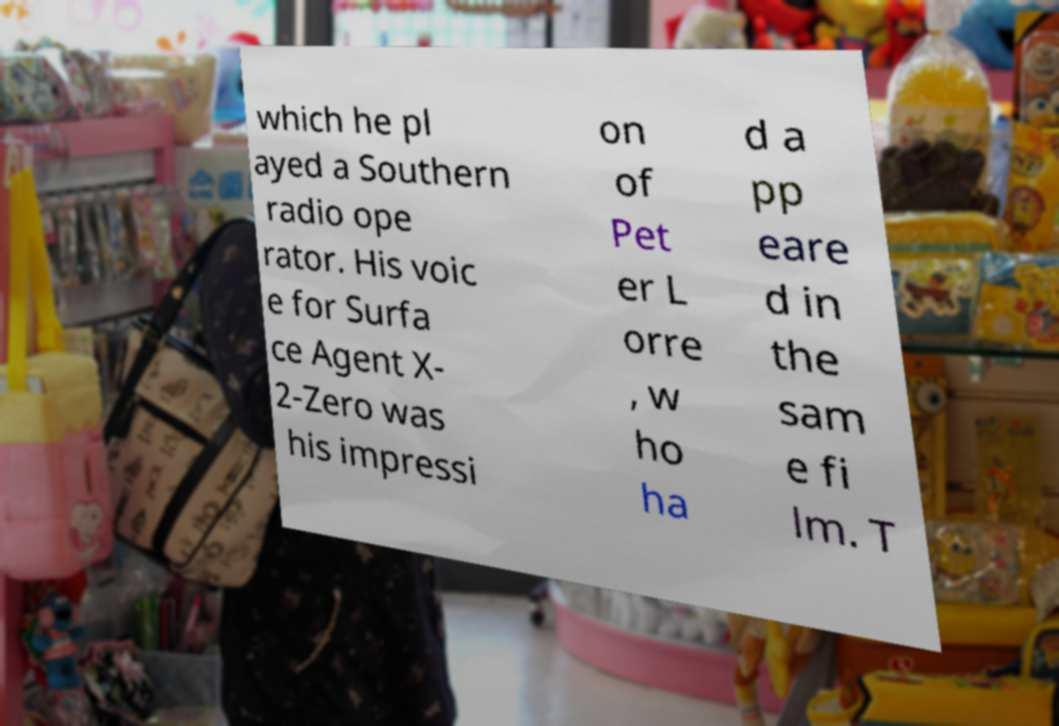Can you accurately transcribe the text from the provided image for me? which he pl ayed a Southern radio ope rator. His voic e for Surfa ce Agent X- 2-Zero was his impressi on of Pet er L orre , w ho ha d a pp eare d in the sam e fi lm. T 